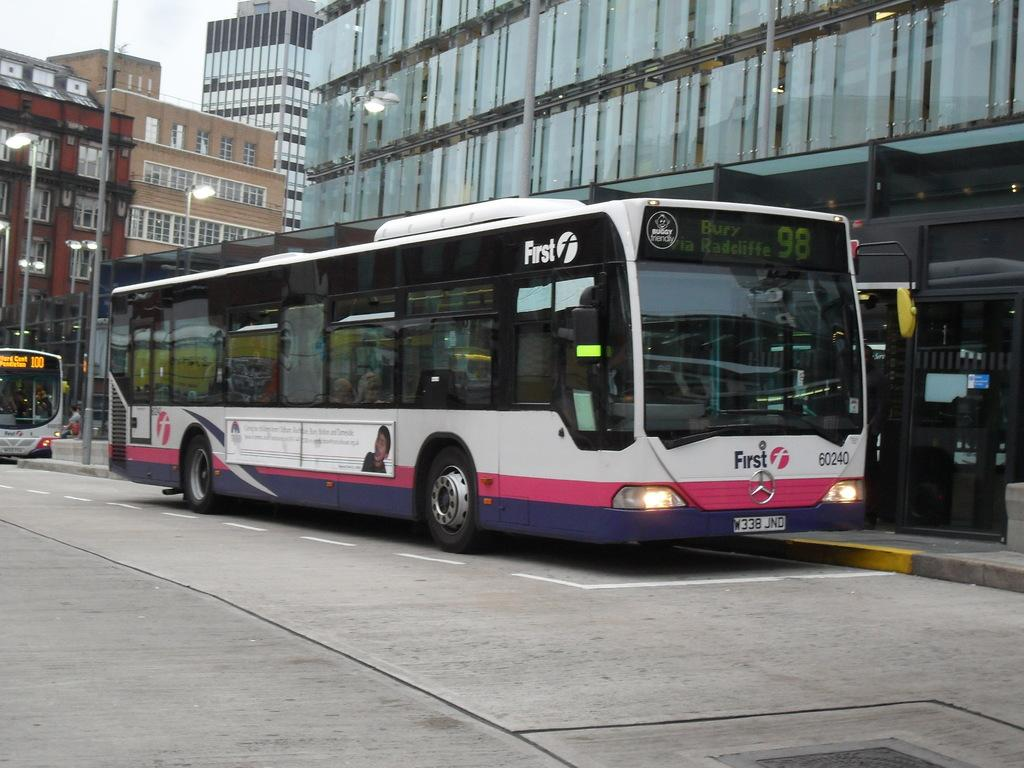<image>
Write a terse but informative summary of the picture. Bus number 60240 has a First logo on the side and front. 